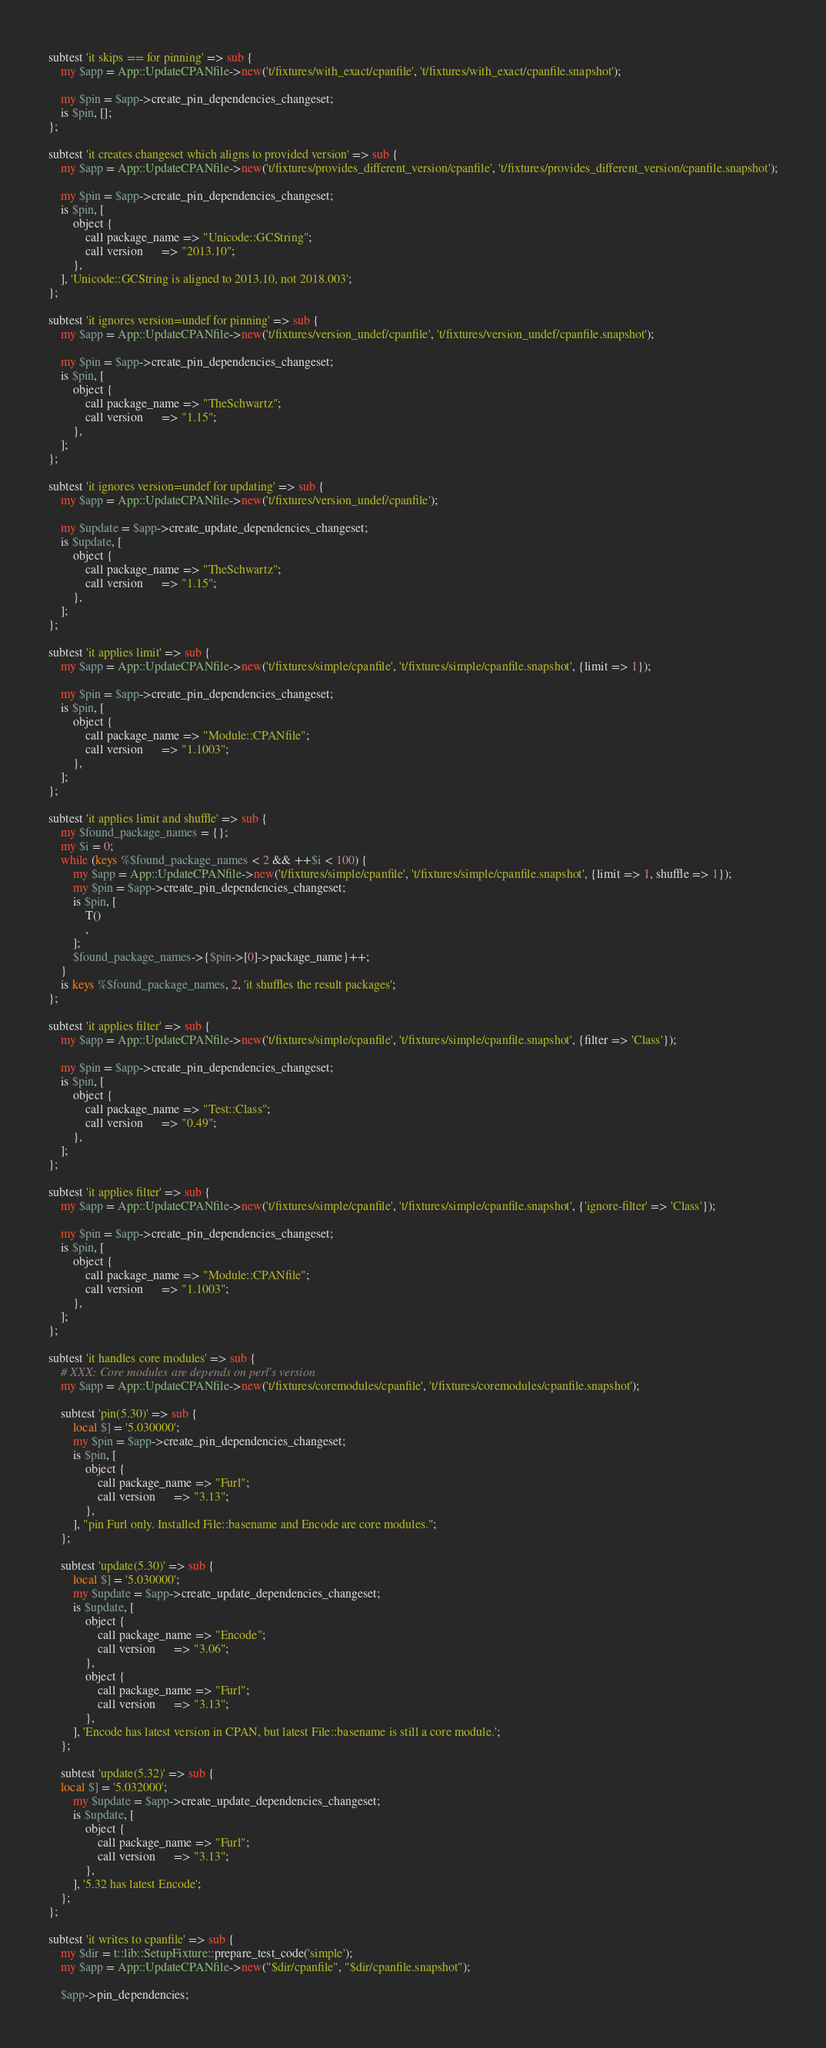Convert code to text. <code><loc_0><loc_0><loc_500><loc_500><_Perl_>
subtest 'it skips == for pinning' => sub {
    my $app = App::UpdateCPANfile->new('t/fixtures/with_exact/cpanfile', 't/fixtures/with_exact/cpanfile.snapshot');

    my $pin = $app->create_pin_dependencies_changeset;
    is $pin, [];
};

subtest 'it creates changeset which aligns to provided version' => sub {
    my $app = App::UpdateCPANfile->new('t/fixtures/provides_different_version/cpanfile', 't/fixtures/provides_different_version/cpanfile.snapshot');

    my $pin = $app->create_pin_dependencies_changeset;
    is $pin, [
        object {
            call package_name => "Unicode::GCString";
            call version      => "2013.10";
        },
    ], 'Unicode::GCString is aligned to 2013.10, not 2018.003';
};

subtest 'it ignores version=undef for pinning' => sub {
    my $app = App::UpdateCPANfile->new('t/fixtures/version_undef/cpanfile', 't/fixtures/version_undef/cpanfile.snapshot');

    my $pin = $app->create_pin_dependencies_changeset;
    is $pin, [
        object {
            call package_name => "TheSchwartz";
            call version      => "1.15";
        },
    ];
};

subtest 'it ignores version=undef for updating' => sub {
    my $app = App::UpdateCPANfile->new('t/fixtures/version_undef/cpanfile');

    my $update = $app->create_update_dependencies_changeset;
    is $update, [
        object {
            call package_name => "TheSchwartz";
            call version      => "1.15";
        },
    ];
};

subtest 'it applies limit' => sub {
    my $app = App::UpdateCPANfile->new('t/fixtures/simple/cpanfile', 't/fixtures/simple/cpanfile.snapshot', {limit => 1});

    my $pin = $app->create_pin_dependencies_changeset;
    is $pin, [
        object {
            call package_name => "Module::CPANfile";
            call version      => "1.1003";
        },
    ];
};

subtest 'it applies limit and shuffle' => sub {
    my $found_package_names = {};
    my $i = 0;
    while (keys %$found_package_names < 2 && ++$i < 100) {
        my $app = App::UpdateCPANfile->new('t/fixtures/simple/cpanfile', 't/fixtures/simple/cpanfile.snapshot', {limit => 1, shuffle => 1});
        my $pin = $app->create_pin_dependencies_changeset;
        is $pin, [
            T()
            ,
        ];
        $found_package_names->{$pin->[0]->package_name}++;
    }
    is keys %$found_package_names, 2, 'it shuffles the result packages';
};

subtest 'it applies filter' => sub {
    my $app = App::UpdateCPANfile->new('t/fixtures/simple/cpanfile', 't/fixtures/simple/cpanfile.snapshot', {filter => 'Class'});

    my $pin = $app->create_pin_dependencies_changeset;
    is $pin, [
        object {
            call package_name => "Test::Class";
            call version      => "0.49";
        },
    ];
};

subtest 'it applies filter' => sub {
    my $app = App::UpdateCPANfile->new('t/fixtures/simple/cpanfile', 't/fixtures/simple/cpanfile.snapshot', {'ignore-filter' => 'Class'});

    my $pin = $app->create_pin_dependencies_changeset;
    is $pin, [
        object {
            call package_name => "Module::CPANfile";
            call version      => "1.1003";
        },
    ];
};

subtest 'it handles core modules' => sub {
    # XXX: Core modules are depends on perl's version
    my $app = App::UpdateCPANfile->new('t/fixtures/coremodules/cpanfile', 't/fixtures/coremodules/cpanfile.snapshot');

    subtest 'pin(5.30)' => sub {
        local $] = '5.030000';
        my $pin = $app->create_pin_dependencies_changeset;
        is $pin, [
            object {
                call package_name => "Furl";
                call version      => "3.13";
            },
        ], "pin Furl only. Installed File::basename and Encode are core modules.";
    };

    subtest 'update(5.30)' => sub {
        local $] = '5.030000';
        my $update = $app->create_update_dependencies_changeset;
        is $update, [
            object {
                call package_name => "Encode";
                call version      => "3.06";
            },
            object {
                call package_name => "Furl";
                call version      => "3.13";
            },
        ], 'Encode has latest version in CPAN, but latest File::basename is still a core module.';
    };

    subtest 'update(5.32)' => sub {
    local $] = '5.032000';
        my $update = $app->create_update_dependencies_changeset;
        is $update, [
            object {
                call package_name => "Furl";
                call version      => "3.13";
            },
        ], '5.32 has latest Encode';
    };
};

subtest 'it writes to cpanfile' => sub {
    my $dir = t::lib::SetupFixture::prepare_test_code('simple');
    my $app = App::UpdateCPANfile->new("$dir/cpanfile", "$dir/cpanfile.snapshot");

    $app->pin_dependencies;
</code> 